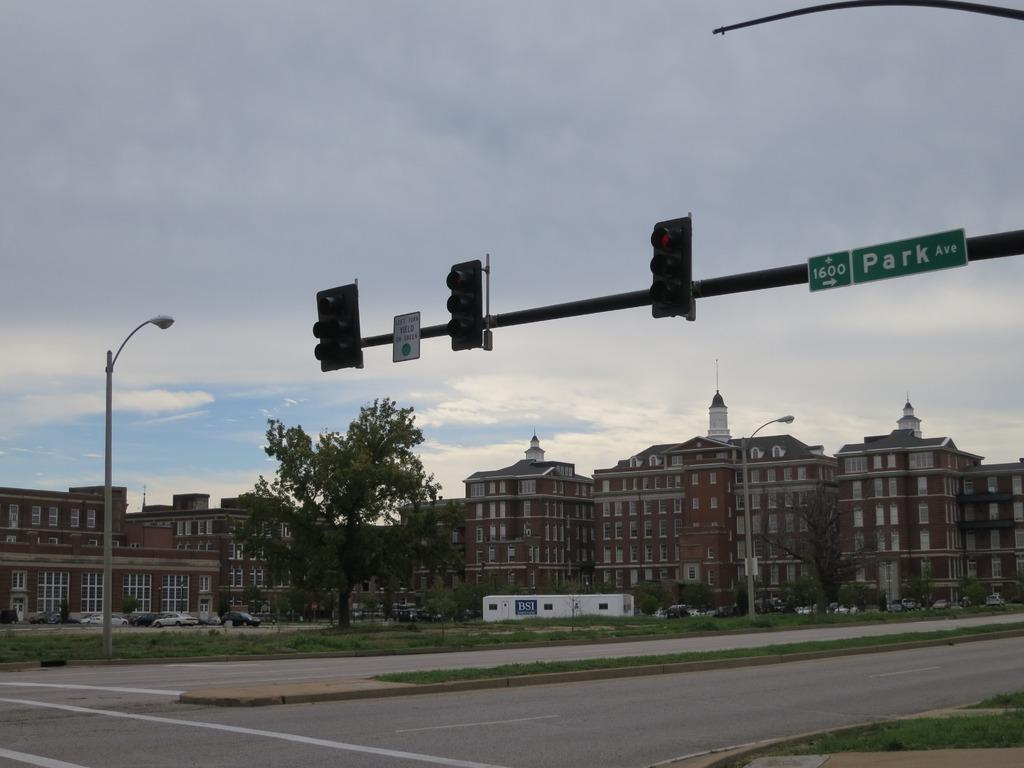<image>
Provide a brief description of the given image. the word park is on the green sign above the street 